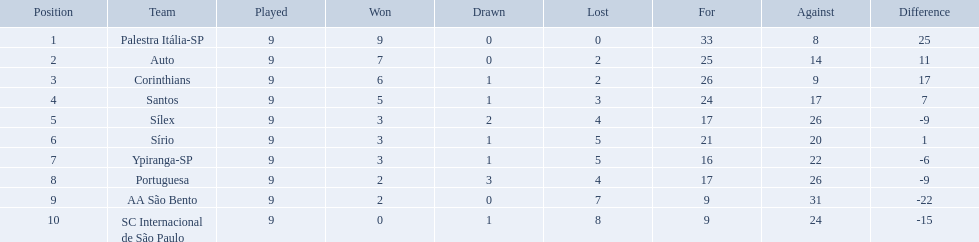How many games did each team play? 9, 9, 9, 9, 9, 9, 9, 9, 9, 9. Did any team score 13 points in the total games they played? 13. What is the name of that team? Corinthians. Which teams were playing brazilian football in 1926? Palestra Itália-SP, Auto, Corinthians, Santos, Sílex, Sírio, Ypiranga-SP, Portuguesa, AA São Bento, SC Internacional de São Paulo. Of those teams, which one scored 13 points? Corinthians. Brazilian football in 1926 what teams had no draws? Palestra Itália-SP, Auto, AA São Bento. Of the teams with no draws name the 2 who lost the lease. Palestra Itália-SP, Auto. Help me parse the entirety of this table. {'header': ['Position', 'Team', 'Played', 'Won', 'Drawn', 'Lost', 'For', 'Against', 'Difference'], 'rows': [['1', 'Palestra Itália-SP', '9', '9', '0', '0', '33', '8', '25'], ['2', 'Auto', '9', '7', '0', '2', '25', '14', '11'], ['3', 'Corinthians', '9', '6', '1', '2', '26', '9', '17'], ['4', 'Santos', '9', '5', '1', '3', '24', '17', '7'], ['5', 'Sílex', '9', '3', '2', '4', '17', '26', '-9'], ['6', 'Sírio', '9', '3', '1', '5', '21', '20', '1'], ['7', 'Ypiranga-SP', '9', '3', '1', '5', '16', '22', '-6'], ['8', 'Portuguesa', '9', '2', '3', '4', '17', '26', '-9'], ['9', 'AA São Bento', '9', '2', '0', '7', '9', '31', '-22'], ['10', 'SC Internacional de São Paulo', '9', '0', '1', '8', '9', '24', '-15']]} What team of the 2 who lost the least and had no draws had the highest difference? Palestra Itália-SP. 